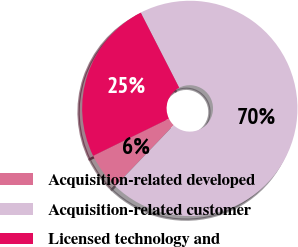<chart> <loc_0><loc_0><loc_500><loc_500><pie_chart><fcel>Acquisition-related developed<fcel>Acquisition-related customer<fcel>Licensed technology and<nl><fcel>5.58%<fcel>69.7%<fcel>24.72%<nl></chart> 